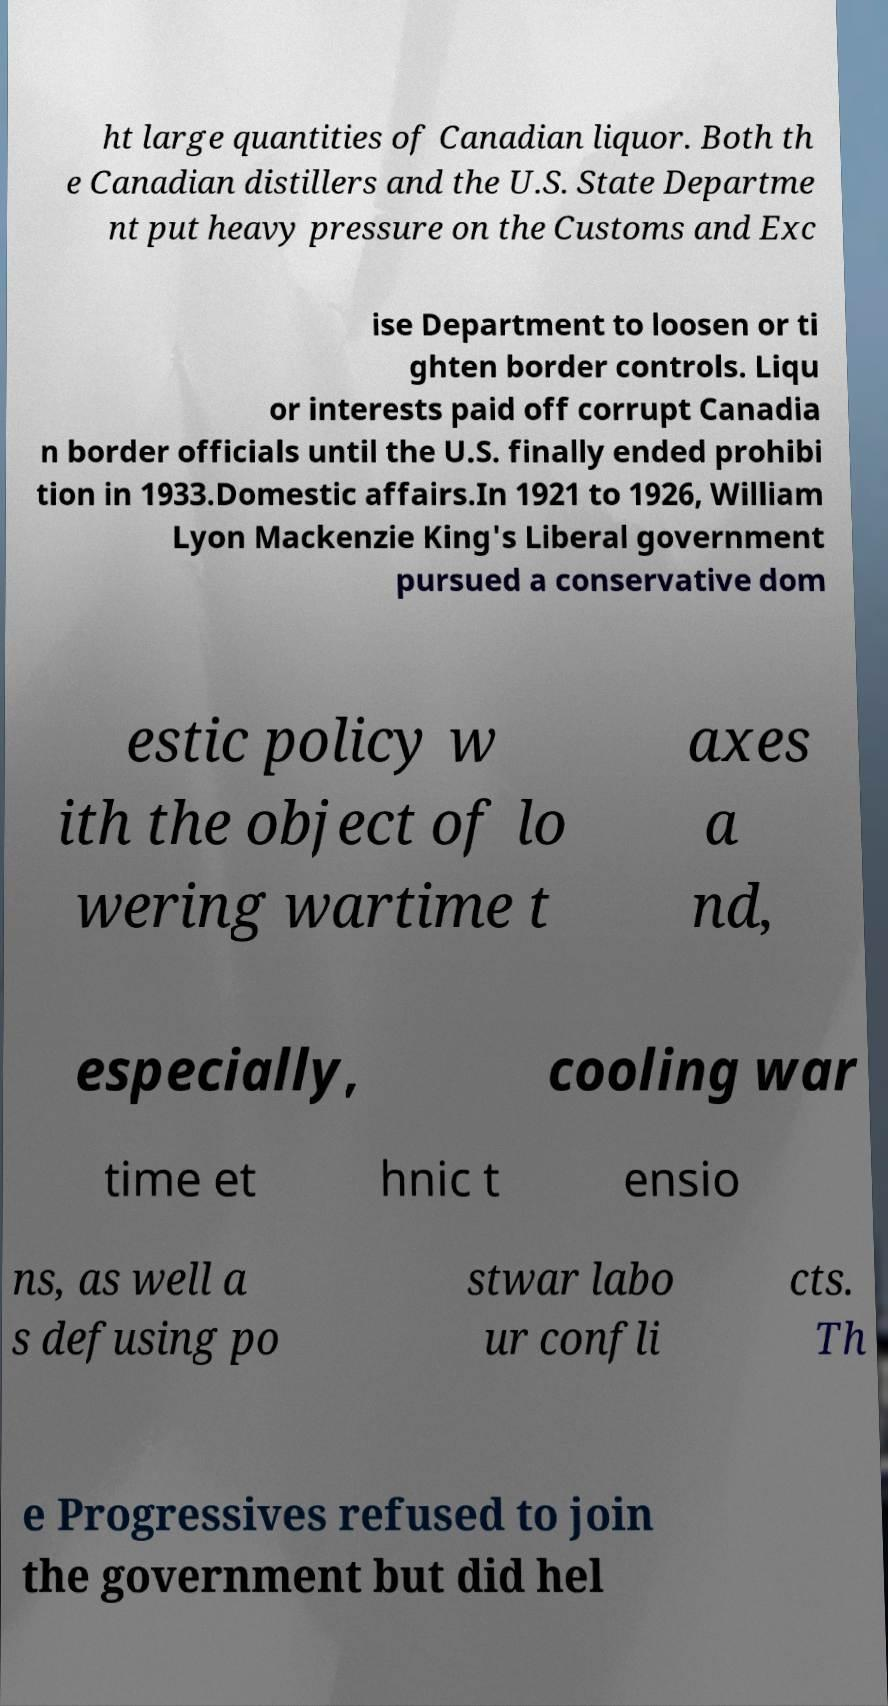What messages or text are displayed in this image? I need them in a readable, typed format. ht large quantities of Canadian liquor. Both th e Canadian distillers and the U.S. State Departme nt put heavy pressure on the Customs and Exc ise Department to loosen or ti ghten border controls. Liqu or interests paid off corrupt Canadia n border officials until the U.S. finally ended prohibi tion in 1933.Domestic affairs.In 1921 to 1926, William Lyon Mackenzie King's Liberal government pursued a conservative dom estic policy w ith the object of lo wering wartime t axes a nd, especially, cooling war time et hnic t ensio ns, as well a s defusing po stwar labo ur confli cts. Th e Progressives refused to join the government but did hel 